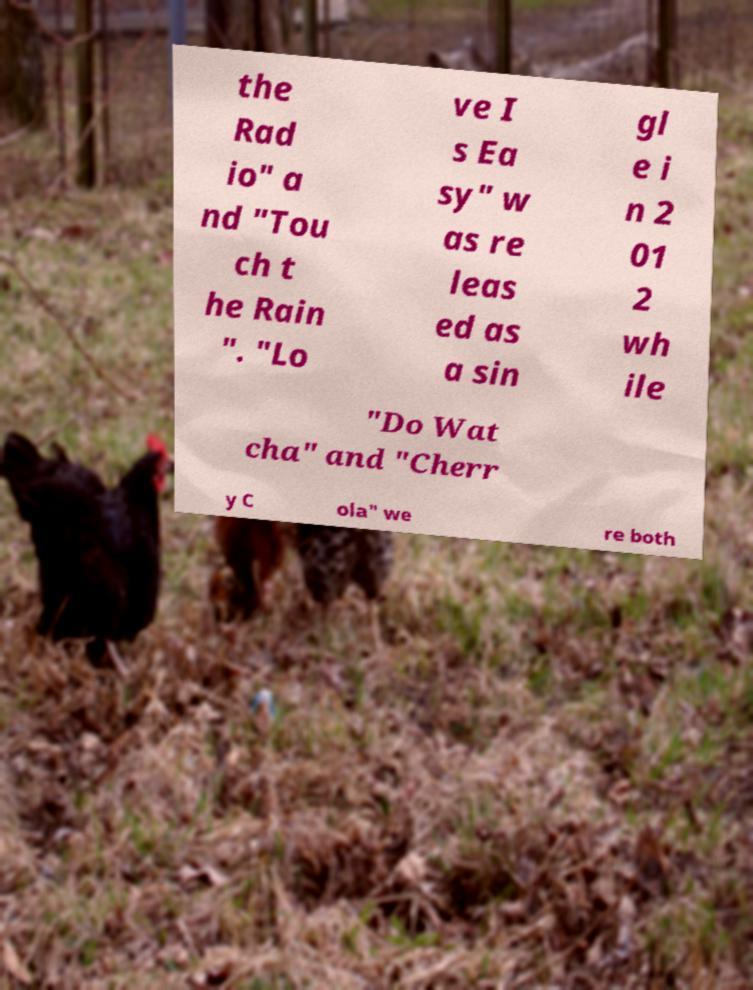For documentation purposes, I need the text within this image transcribed. Could you provide that? the Rad io" a nd "Tou ch t he Rain ". "Lo ve I s Ea sy" w as re leas ed as a sin gl e i n 2 01 2 wh ile "Do Wat cha" and "Cherr y C ola" we re both 